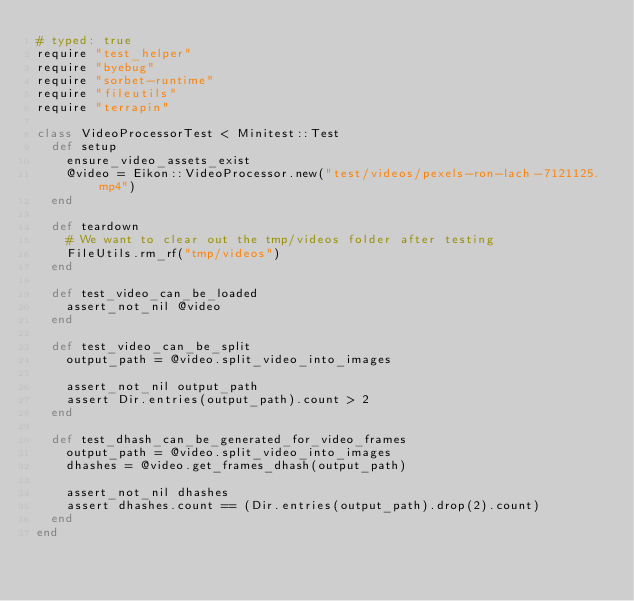<code> <loc_0><loc_0><loc_500><loc_500><_Ruby_># typed: true
require "test_helper"
require "byebug"
require "sorbet-runtime"
require "fileutils"
require "terrapin"

class VideoProcessorTest < Minitest::Test
  def setup
    ensure_video_assets_exist
    @video = Eikon::VideoProcessor.new("test/videos/pexels-ron-lach-7121125.mp4")
  end

  def teardown
    # We want to clear out the tmp/videos folder after testing
    FileUtils.rm_rf("tmp/videos")
  end

  def test_video_can_be_loaded
    assert_not_nil @video
  end

  def test_video_can_be_split
    output_path = @video.split_video_into_images

    assert_not_nil output_path
    assert Dir.entries(output_path).count > 2
  end

  def test_dhash_can_be_generated_for_video_frames
    output_path = @video.split_video_into_images
    dhashes = @video.get_frames_dhash(output_path)

    assert_not_nil dhashes
    assert dhashes.count == (Dir.entries(output_path).drop(2).count)
  end
end
</code> 